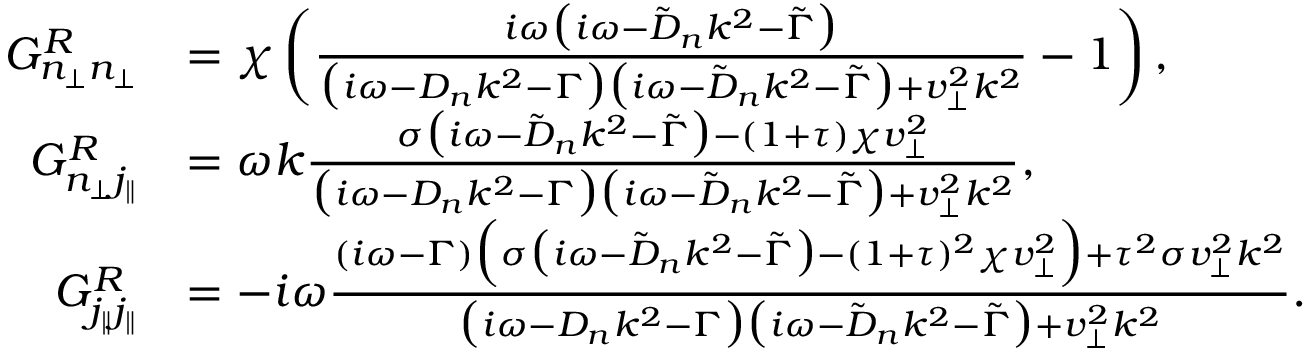Convert formula to latex. <formula><loc_0><loc_0><loc_500><loc_500>\begin{array} { r l } { G _ { n _ { \perp } n _ { \perp } } ^ { R } } & { = \chi \left ( \frac { i \omega \left ( i \omega - \tilde { D } _ { n } k ^ { 2 } - \tilde { \Gamma } \right ) } { \left ( i \omega - D _ { n } k ^ { 2 } - \Gamma \right ) \left ( i \omega - \tilde { D } _ { n } k ^ { 2 } - \tilde { \Gamma } \right ) + v _ { \perp } ^ { 2 } k ^ { 2 } } - 1 \right ) , } \\ { G _ { n _ { \perp } j _ { \| } } ^ { R } } & { = \omega k \frac { \sigma \left ( i \omega - \tilde { D } _ { n } k ^ { 2 } - \tilde { \Gamma } \right ) - ( 1 + \tau ) \chi v _ { \perp } ^ { 2 } } { \left ( i \omega - D _ { n } k ^ { 2 } - \Gamma \right ) \left ( i \omega - \tilde { D } _ { n } k ^ { 2 } - \tilde { \Gamma } \right ) + v _ { \perp } ^ { 2 } k ^ { 2 } } , } \\ { G _ { j _ { \| } j _ { \| } } ^ { R } } & { = - i \omega \frac { ( i \omega - \Gamma ) \left ( \sigma \left ( i \omega - \tilde { D } _ { n } k ^ { 2 } - \tilde { \Gamma } \right ) - ( 1 + \tau ) ^ { 2 } \chi v _ { \perp } ^ { 2 } \right ) + \tau ^ { 2 } \sigma v _ { \perp } ^ { 2 } k ^ { 2 } } { \left ( i \omega - D _ { n } k ^ { 2 } - \Gamma \right ) \left ( i \omega - \tilde { D } _ { n } k ^ { 2 } - \tilde { \Gamma } \right ) + v _ { \perp } ^ { 2 } k ^ { 2 } } . } \end{array}</formula> 